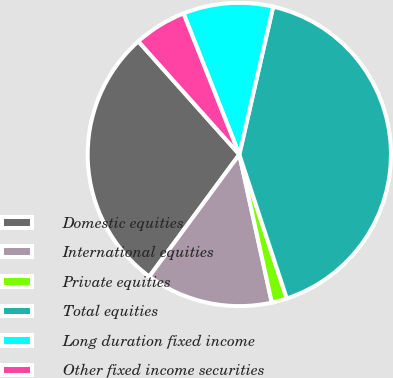Convert chart. <chart><loc_0><loc_0><loc_500><loc_500><pie_chart><fcel>Domestic equities<fcel>International equities<fcel>Private equities<fcel>Total equities<fcel>Long duration fixed income<fcel>Other fixed income securities<nl><fcel>28.29%<fcel>13.55%<fcel>1.63%<fcel>41.35%<fcel>9.58%<fcel>5.6%<nl></chart> 